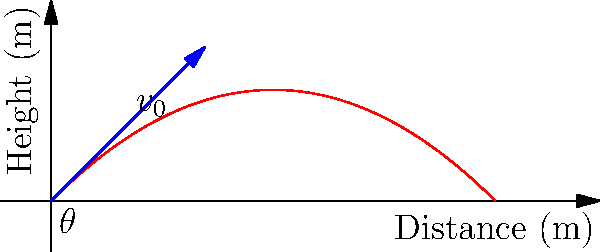In the game Candy Box, you're developing a new candy weapon that follows a parabolic trajectory. The weapon is launched with an initial velocity $v_0 = 20$ m/s at an angle $\theta = 45°$ to the horizontal. Assuming no air resistance, what is the maximum height reached by the candy weapon? To find the maximum height, we'll follow these steps:

1) The vertical component of velocity is given by $v_y = v_0 \sin(\theta)$.

2) At the highest point, the vertical velocity becomes zero. We can use the equation:
   $v_y^2 = v_0^2 \sin^2(\theta) - 2gh_{max}$
   
   Where $h_{max}$ is the maximum height and $g$ is the acceleration due to gravity (9.8 m/s²).

3) Setting $v_y = 0$ at the highest point:
   $0 = v_0^2 \sin^2(\theta) - 2gh_{max}$

4) Solving for $h_{max}$:
   $h_{max} = \frac{v_0^2 \sin^2(\theta)}{2g}$

5) Substituting the given values:
   $h_{max} = \frac{(20 \text{ m/s})^2 \sin^2(45°)}{2(9.8 \text{ m/s}^2)}$

6) Simplify:
   $h_{max} = \frac{400 \cdot 0.5}{19.6} = 10.2 \text{ m}$

Therefore, the maximum height reached by the candy weapon is approximately 10.2 meters.
Answer: 10.2 m 